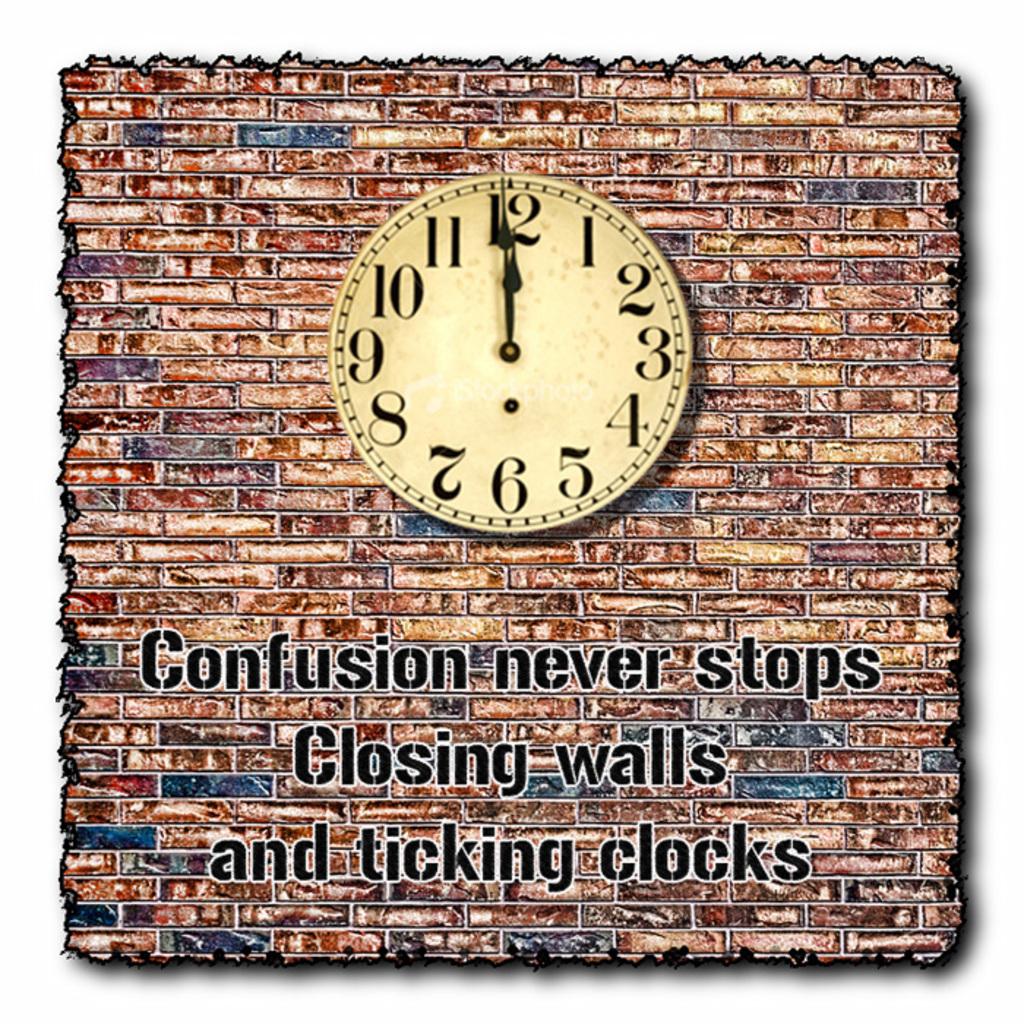What never stops?
Your answer should be compact. Confusion. What are closing?
Offer a terse response. Walls. 